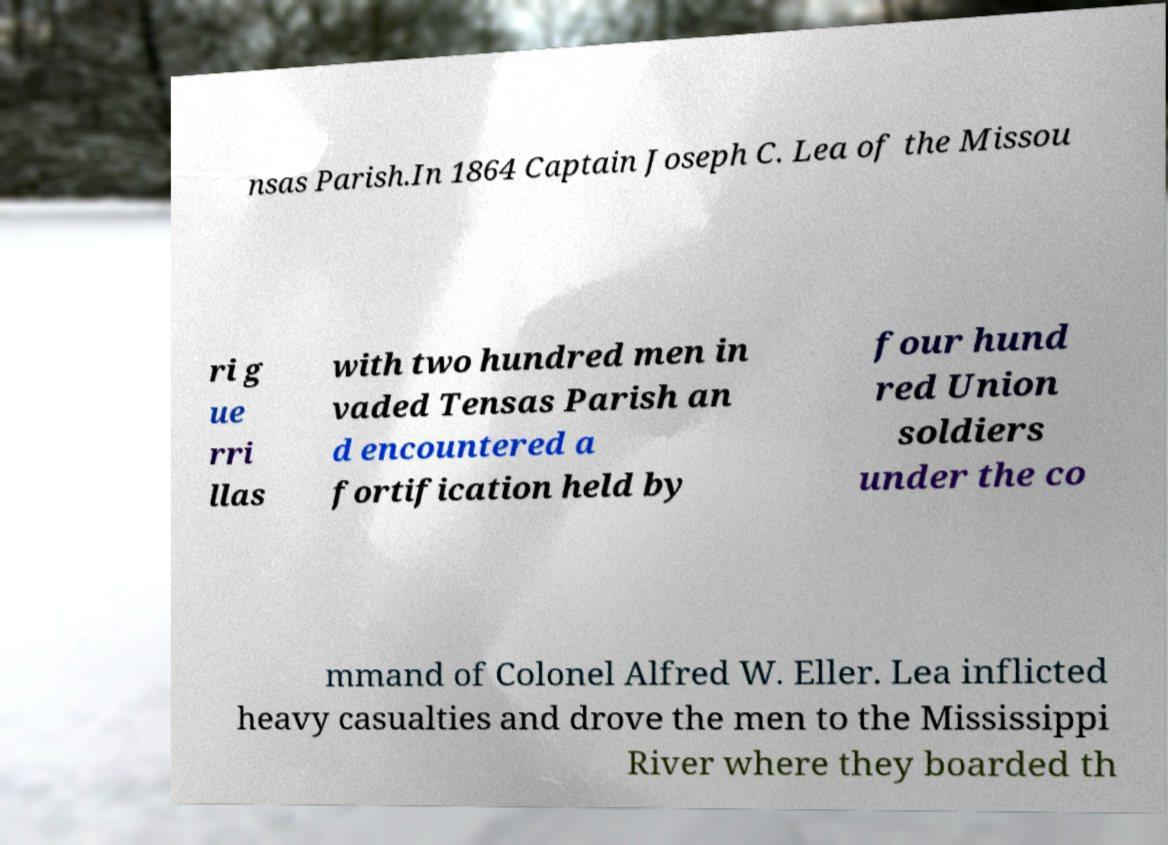There's text embedded in this image that I need extracted. Can you transcribe it verbatim? nsas Parish.In 1864 Captain Joseph C. Lea of the Missou ri g ue rri llas with two hundred men in vaded Tensas Parish an d encountered a fortification held by four hund red Union soldiers under the co mmand of Colonel Alfred W. Eller. Lea inflicted heavy casualties and drove the men to the Mississippi River where they boarded th 